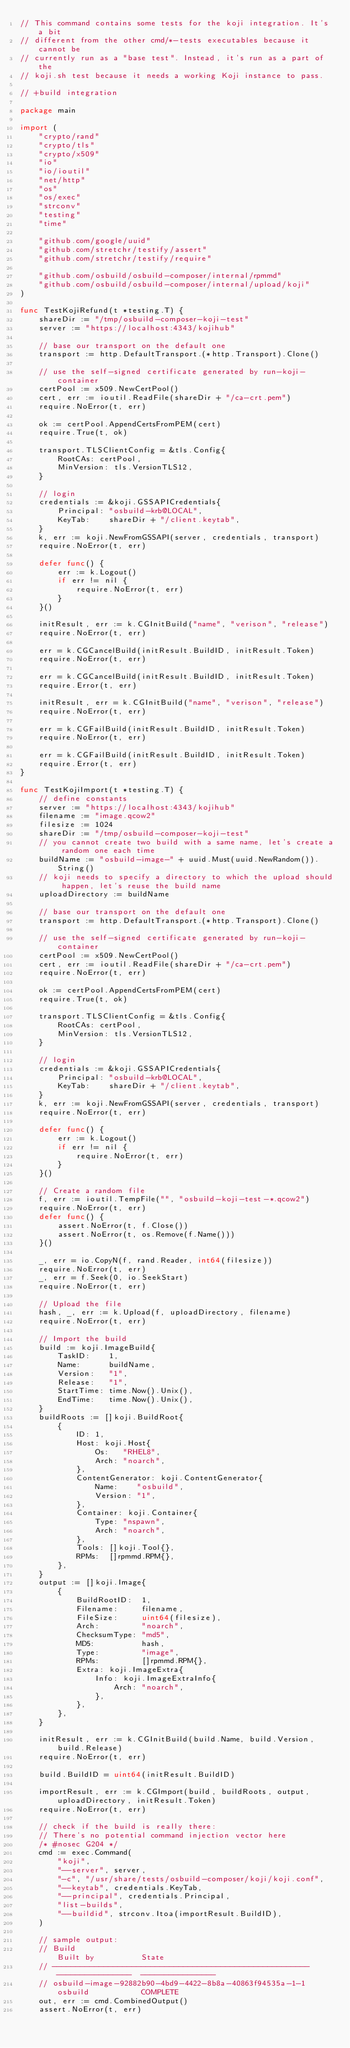<code> <loc_0><loc_0><loc_500><loc_500><_Go_>// This command contains some tests for the koji integration. It's a bit
// different from the other cmd/*-tests executables because it cannot be
// currently run as a "base test". Instead, it's run as a part of the
// koji.sh test because it needs a working Koji instance to pass.

// +build integration

package main

import (
	"crypto/rand"
	"crypto/tls"
	"crypto/x509"
	"io"
	"io/ioutil"
	"net/http"
	"os"
	"os/exec"
	"strconv"
	"testing"
	"time"

	"github.com/google/uuid"
	"github.com/stretchr/testify/assert"
	"github.com/stretchr/testify/require"

	"github.com/osbuild/osbuild-composer/internal/rpmmd"
	"github.com/osbuild/osbuild-composer/internal/upload/koji"
)

func TestKojiRefund(t *testing.T) {
	shareDir := "/tmp/osbuild-composer-koji-test"
	server := "https://localhost:4343/kojihub"

	// base our transport on the default one
	transport := http.DefaultTransport.(*http.Transport).Clone()

	// use the self-signed certificate generated by run-koji-container
	certPool := x509.NewCertPool()
	cert, err := ioutil.ReadFile(shareDir + "/ca-crt.pem")
	require.NoError(t, err)

	ok := certPool.AppendCertsFromPEM(cert)
	require.True(t, ok)

	transport.TLSClientConfig = &tls.Config{
		RootCAs: certPool,
		MinVersion: tls.VersionTLS12,
	}

	// login
	credentials := &koji.GSSAPICredentials{
		Principal: "osbuild-krb@LOCAL",
		KeyTab:    shareDir + "/client.keytab",
	}
	k, err := koji.NewFromGSSAPI(server, credentials, transport)
	require.NoError(t, err)

	defer func() {
		err := k.Logout()
		if err != nil {
			require.NoError(t, err)
		}
	}()

	initResult, err := k.CGInitBuild("name", "verison", "release")
	require.NoError(t, err)

	err = k.CGCancelBuild(initResult.BuildID, initResult.Token)
	require.NoError(t, err)

	err = k.CGCancelBuild(initResult.BuildID, initResult.Token)
	require.Error(t, err)

	initResult, err = k.CGInitBuild("name", "verison", "release")
	require.NoError(t, err)

	err = k.CGFailBuild(initResult.BuildID, initResult.Token)
	require.NoError(t, err)

	err = k.CGFailBuild(initResult.BuildID, initResult.Token)
	require.Error(t, err)
}

func TestKojiImport(t *testing.T) {
	// define constants
	server := "https://localhost:4343/kojihub"
	filename := "image.qcow2"
	filesize := 1024
	shareDir := "/tmp/osbuild-composer-koji-test"
	// you cannot create two build with a same name, let's create a random one each time
	buildName := "osbuild-image-" + uuid.Must(uuid.NewRandom()).String()
	// koji needs to specify a directory to which the upload should happen, let's reuse the build name
	uploadDirectory := buildName

	// base our transport on the default one
	transport := http.DefaultTransport.(*http.Transport).Clone()

	// use the self-signed certificate generated by run-koji-container
	certPool := x509.NewCertPool()
	cert, err := ioutil.ReadFile(shareDir + "/ca-crt.pem")
	require.NoError(t, err)

	ok := certPool.AppendCertsFromPEM(cert)
	require.True(t, ok)

	transport.TLSClientConfig = &tls.Config{
		RootCAs: certPool,
		MinVersion: tls.VersionTLS12,
	}

	// login
	credentials := &koji.GSSAPICredentials{
		Principal: "osbuild-krb@LOCAL",
		KeyTab:    shareDir + "/client.keytab",
	}
	k, err := koji.NewFromGSSAPI(server, credentials, transport)
	require.NoError(t, err)

	defer func() {
		err := k.Logout()
		if err != nil {
			require.NoError(t, err)
		}
	}()

	// Create a random file
	f, err := ioutil.TempFile("", "osbuild-koji-test-*.qcow2")
	require.NoError(t, err)
	defer func() {
		assert.NoError(t, f.Close())
		assert.NoError(t, os.Remove(f.Name()))
	}()

	_, err = io.CopyN(f, rand.Reader, int64(filesize))
	require.NoError(t, err)
	_, err = f.Seek(0, io.SeekStart)
	require.NoError(t, err)

	// Upload the file
	hash, _, err := k.Upload(f, uploadDirectory, filename)
	require.NoError(t, err)

	// Import the build
	build := koji.ImageBuild{
		TaskID:    1,
		Name:      buildName,
		Version:   "1",
		Release:   "1",
		StartTime: time.Now().Unix(),
		EndTime:   time.Now().Unix(),
	}
	buildRoots := []koji.BuildRoot{
		{
			ID: 1,
			Host: koji.Host{
				Os:   "RHEL8",
				Arch: "noarch",
			},
			ContentGenerator: koji.ContentGenerator{
				Name:    "osbuild",
				Version: "1",
			},
			Container: koji.Container{
				Type: "nspawn",
				Arch: "noarch",
			},
			Tools: []koji.Tool{},
			RPMs:  []rpmmd.RPM{},
		},
	}
	output := []koji.Image{
		{
			BuildRootID:  1,
			Filename:     filename,
			FileSize:     uint64(filesize),
			Arch:         "noarch",
			ChecksumType: "md5",
			MD5:          hash,
			Type:         "image",
			RPMs:         []rpmmd.RPM{},
			Extra: koji.ImageExtra{
				Info: koji.ImageExtraInfo{
					Arch: "noarch",
				},
			},
		},
	}

	initResult, err := k.CGInitBuild(build.Name, build.Version, build.Release)
	require.NoError(t, err)

	build.BuildID = uint64(initResult.BuildID)

	importResult, err := k.CGImport(build, buildRoots, output, uploadDirectory, initResult.Token)
	require.NoError(t, err)

	// check if the build is really there:
	// There's no potential command injection vector here
	/* #nosec G204 */
	cmd := exec.Command(
		"koji",
		"--server", server,
		"-c", "/usr/share/tests/osbuild-composer/koji/koji.conf",
		"--keytab", credentials.KeyTab,
		"--principal", credentials.Principal,
		"list-builds",
		"--buildid", strconv.Itoa(importResult.BuildID),
	)

	// sample output:
	// Build                                                    Built by          State
	// -------------------------------------------------------  ----------------  ----------------
	// osbuild-image-92882b90-4bd9-4422-8b8a-40863f94535a-1-1   osbuild           COMPLETE
	out, err := cmd.CombinedOutput()
	assert.NoError(t, err)
</code> 